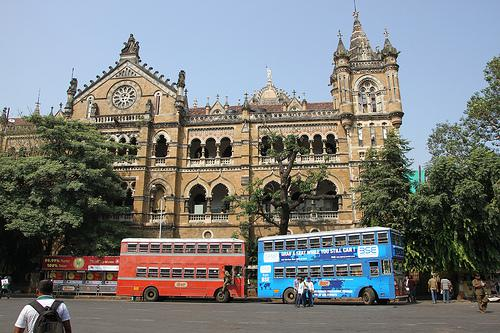Question: what is in front of building?
Choices:
A. Cabs.
B. Buses.
C. Scooters.
D. Bicycles.
Answer with the letter. Answer: B Question: when was this photo taken?
Choices:
A. At night.
B. At the pier.
C. In the daytime.
D. At dusk.
Answer with the letter. Answer: C Question: what color are the trees?
Choices:
A. Brown.
B. Black.
C. Red.
D. Green.
Answer with the letter. Answer: D Question: where was this photo taken?
Choices:
A. In the country.
B. In the sky.
C. On a city street.
D. Underwater.
Answer with the letter. Answer: C Question: what color are the buses?
Choices:
A. Blue and red.
B. Yellow.
C. White.
D. Silver.
Answer with the letter. Answer: A 